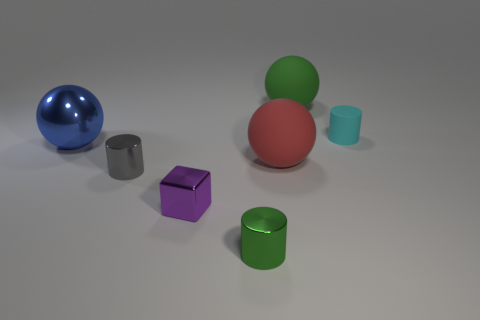Add 2 tiny purple blocks. How many objects exist? 9 Subtract all spheres. How many objects are left? 4 Subtract all small purple objects. Subtract all shiny things. How many objects are left? 2 Add 2 cyan cylinders. How many cyan cylinders are left? 3 Add 3 tiny gray spheres. How many tiny gray spheres exist? 3 Subtract 0 blue cylinders. How many objects are left? 7 